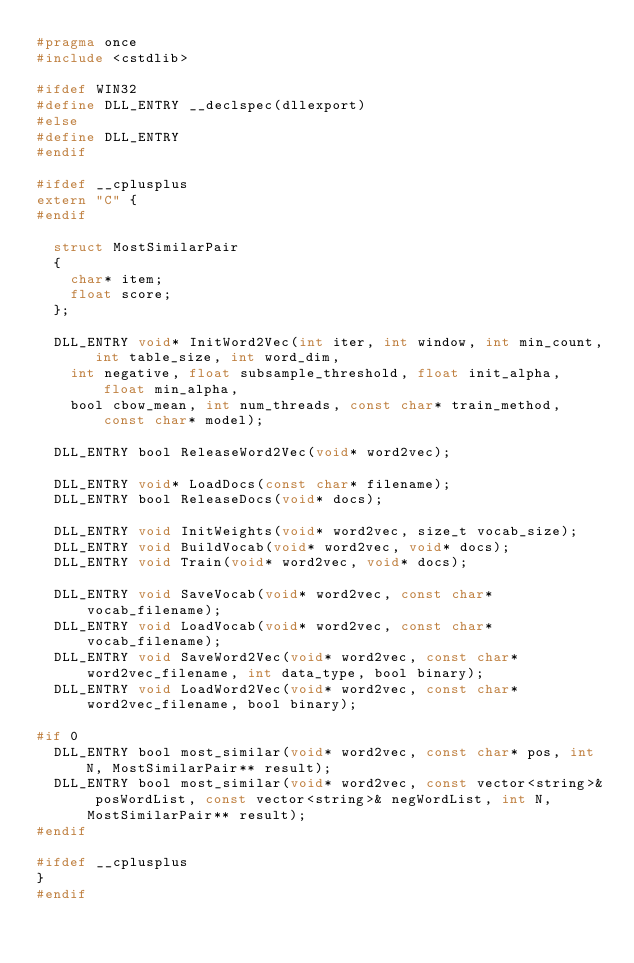Convert code to text. <code><loc_0><loc_0><loc_500><loc_500><_C_>#pragma once
#include <cstdlib>

#ifdef WIN32
#define DLL_ENTRY __declspec(dllexport)
#else
#define DLL_ENTRY
#endif

#ifdef __cplusplus
extern "C" {
#endif

	struct MostSimilarPair
	{
		char* item;
		float score;
	};

	DLL_ENTRY void* InitWord2Vec(int iter, int window, int min_count, int table_size, int word_dim,
		int negative, float subsample_threshold, float init_alpha, float min_alpha,
		bool cbow_mean, int num_threads, const char* train_method, const char* model);

	DLL_ENTRY bool ReleaseWord2Vec(void* word2vec);

	DLL_ENTRY void* LoadDocs(const char* filename);
	DLL_ENTRY bool ReleaseDocs(void* docs);

	DLL_ENTRY void InitWeights(void* word2vec, size_t vocab_size);
	DLL_ENTRY void BuildVocab(void* word2vec, void* docs);
	DLL_ENTRY void Train(void* word2vec, void* docs);

	DLL_ENTRY void SaveVocab(void* word2vec, const char* vocab_filename);
	DLL_ENTRY void LoadVocab(void* word2vec, const char* vocab_filename);
	DLL_ENTRY void SaveWord2Vec(void* word2vec, const char* word2vec_filename, int data_type, bool binary);
	DLL_ENTRY void LoadWord2Vec(void* word2vec, const char* word2vec_filename, bool binary);

#if 0
	DLL_ENTRY bool most_similar(void* word2vec, const char* pos, int N, MostSimilarPair** result);
	DLL_ENTRY bool most_similar(void* word2vec, const vector<string>& posWordList, const vector<string>& negWordList, int N, MostSimilarPair** result);
#endif

#ifdef __cplusplus
}
#endif
</code> 